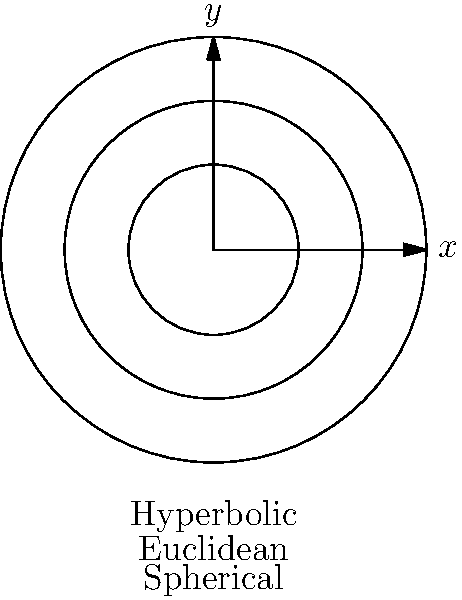In the context of non-Euclidean geometry, consider the diagram showing representations of hyperbolic, Euclidean, and spherical spaces. How does the curvature of space differ in these models, and what implications does this have for the sum of angles in a triangle drawn in each space? To understand the curvature of space in different non-Euclidean models, let's examine each model step-by-step:

1. Euclidean space (middle circle):
   - Has zero curvature (flat space)
   - Parallel lines remain equidistant
   - Sum of angles in a triangle = 180°

2. Hyperbolic space (outer circle):
   - Has negative curvature (saddle-shaped)
   - Parallel lines diverge
   - Sum of angles in a triangle < 180°

3. Spherical space (inner circle):
   - Has positive curvature (sphere-shaped)
   - Parallel lines converge
   - Sum of angles in a triangle > 180°

The curvature of space affects the behavior of geometric objects:

4. In Euclidean space:
   - Straight lines are truly straight
   - The shortest distance between two points is a straight line

5. In hyperbolic space:
   - "Straight" lines curve away from each other
   - The shortest distance between two points is a curved line

6. In spherical space:
   - "Straight" lines curve towards each other
   - The shortest distance between two points is an arc of a great circle

7. Implications for triangles:
   - Euclidean: The sum of angles is exactly 180°
   - Hyperbolic: The sum of angles is less than 180°
   - Spherical: The sum of angles is greater than 180°

8. These differences in curvature lead to distinct geometries with unique properties, affecting various mathematical and physical concepts, including the nature of parallel lines, the behavior of light rays, and the shape of geodesics (shortest paths between points).
Answer: Curvature: Hyperbolic (negative), Euclidean (zero), Spherical (positive). Triangle angle sums: Hyperbolic (<180°), Euclidean (=180°), Spherical (>180°). 